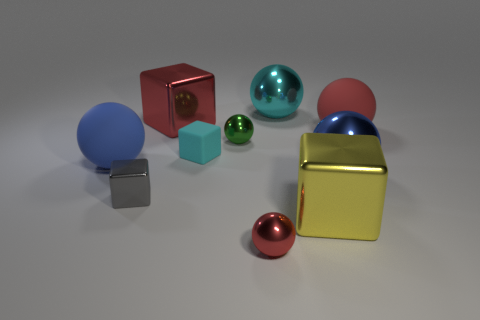There is a ball that is the same size as the green metal thing; what is its material?
Your response must be concise. Metal. There is a red rubber sphere; what number of tiny blocks are in front of it?
Your answer should be very brief. 2. Is the material of the big blue object that is left of the tiny red sphere the same as the big cube behind the blue metal thing?
Offer a very short reply. No. There is a large red object that is behind the big red thing that is right of the tiny sphere in front of the gray metal object; what is its shape?
Keep it short and to the point. Cube. What is the shape of the blue metal thing?
Your answer should be very brief. Sphere. There is a blue rubber object that is the same size as the yellow metal cube; what shape is it?
Provide a succinct answer. Sphere. What number of other things are there of the same color as the matte block?
Provide a succinct answer. 1. Do the big red object that is to the right of the red shiny ball and the small metallic object that is in front of the big yellow metal thing have the same shape?
Provide a succinct answer. Yes. How many objects are either large matte objects on the left side of the gray metal cube or big blue rubber balls that are behind the small gray object?
Your answer should be very brief. 1. How many other objects are there of the same material as the tiny red sphere?
Make the answer very short. 6. 